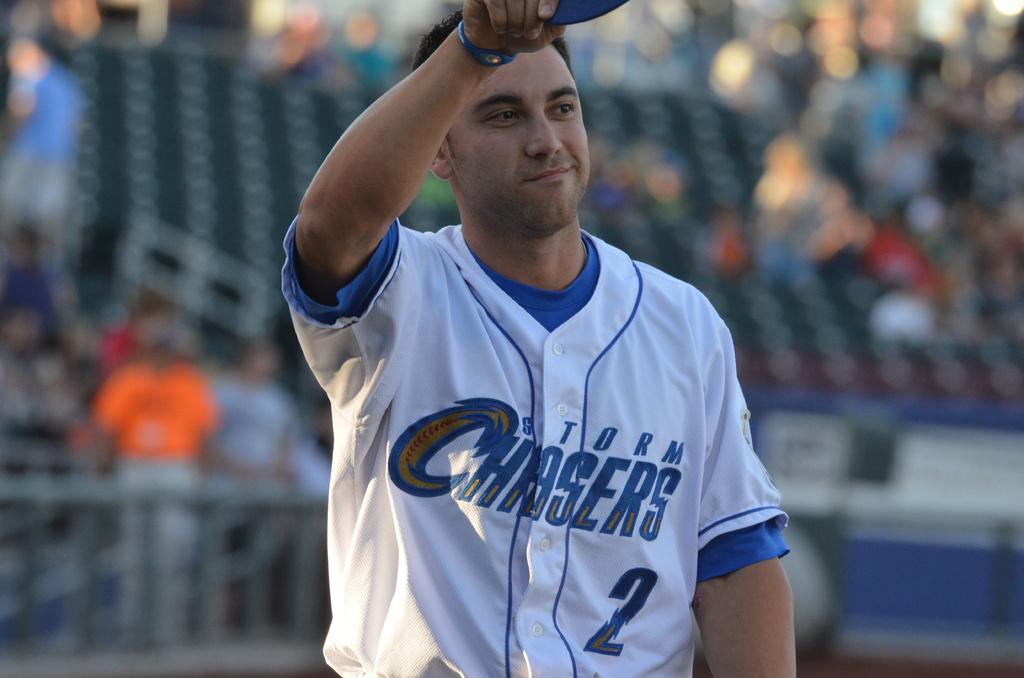What is the players jersey number?
Ensure brevity in your answer.  2. 